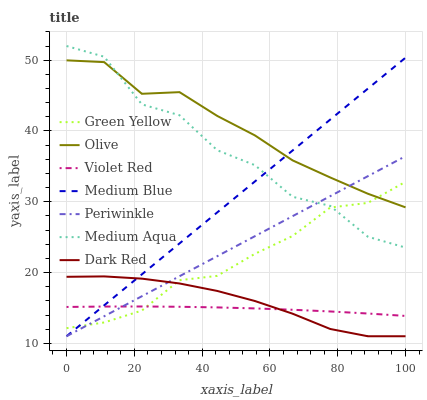Does Dark Red have the minimum area under the curve?
Answer yes or no. No. Does Dark Red have the maximum area under the curve?
Answer yes or no. No. Is Dark Red the smoothest?
Answer yes or no. No. Is Dark Red the roughest?
Answer yes or no. No. Does Olive have the lowest value?
Answer yes or no. No. Does Dark Red have the highest value?
Answer yes or no. No. Is Violet Red less than Medium Aqua?
Answer yes or no. Yes. Is Medium Aqua greater than Dark Red?
Answer yes or no. Yes. Does Violet Red intersect Medium Aqua?
Answer yes or no. No. 